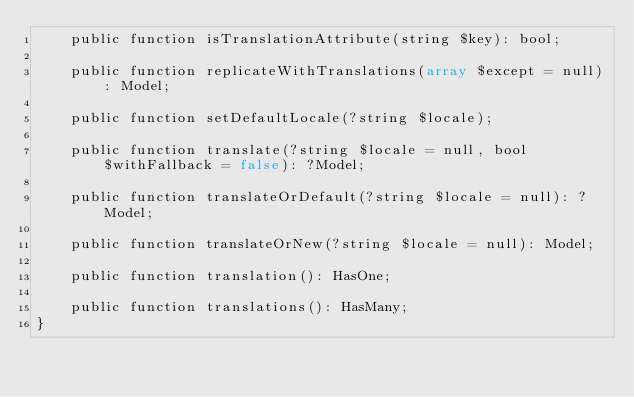<code> <loc_0><loc_0><loc_500><loc_500><_PHP_>    public function isTranslationAttribute(string $key): bool;

    public function replicateWithTranslations(array $except = null): Model;

    public function setDefaultLocale(?string $locale);

    public function translate(?string $locale = null, bool $withFallback = false): ?Model;

    public function translateOrDefault(?string $locale = null): ?Model;

    public function translateOrNew(?string $locale = null): Model;

    public function translation(): HasOne;

    public function translations(): HasMany;
}
</code> 